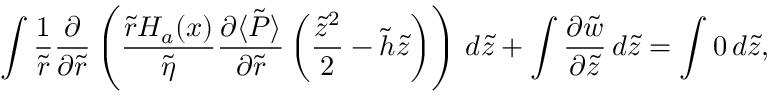<formula> <loc_0><loc_0><loc_500><loc_500>\int \frac { 1 } { \tilde { r } } \frac { \partial } { \partial \tilde { r } } \left ( \frac { \tilde { r } H _ { a } ( x ) } { \tilde { \eta } } \frac { \partial \langle \tilde { P } \rangle } { \partial \tilde { r } } \left ( \frac { \tilde { z } ^ { 2 } } { 2 } - \tilde { h } \tilde { z } \right ) \right ) \, d \tilde { z } + \int \frac { \partial \tilde { w } } { \partial \tilde { z } } \, d \tilde { z } = \int 0 \, d \tilde { z } ,</formula> 